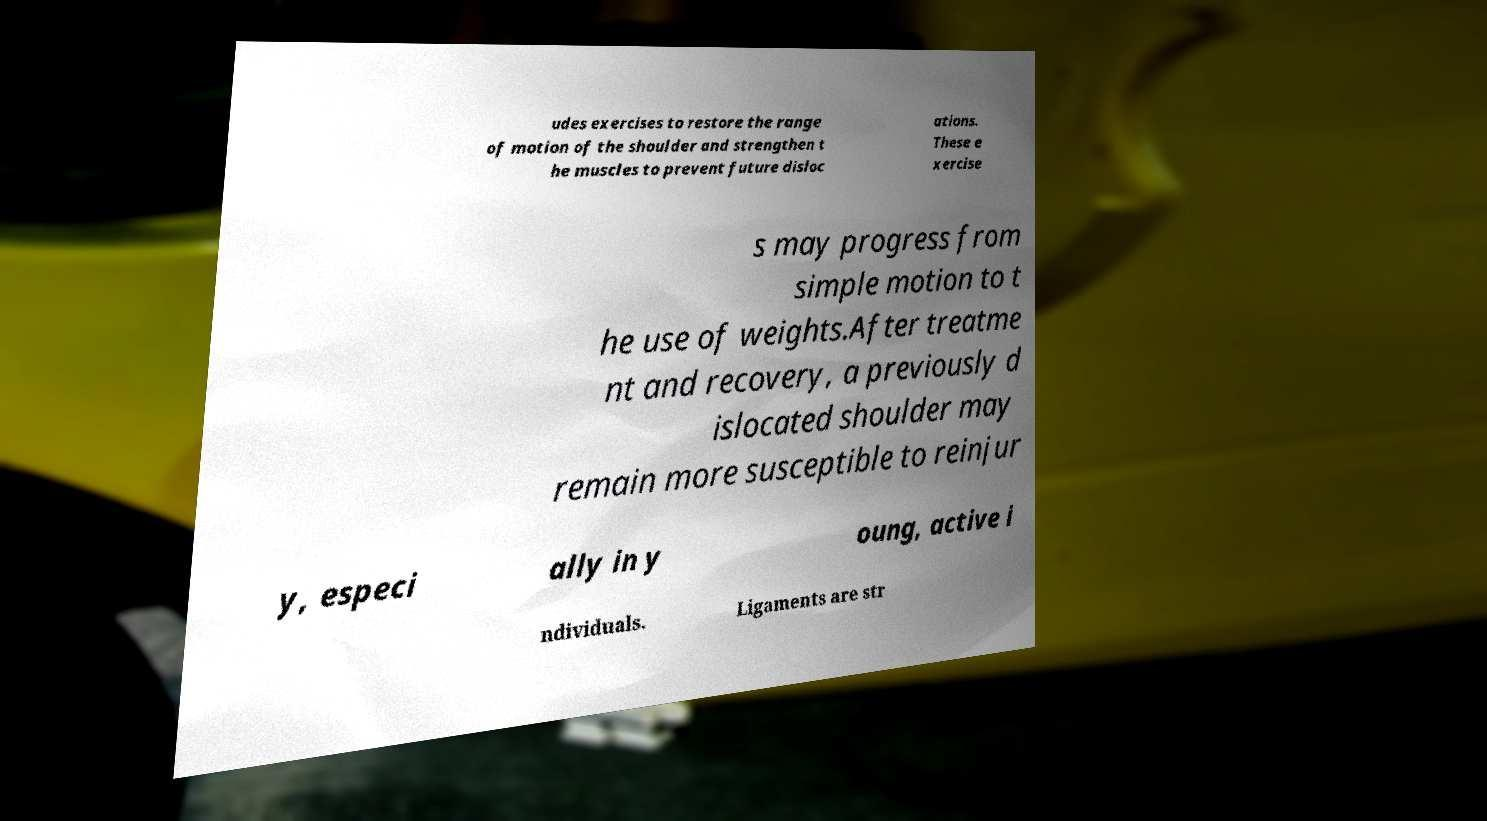Could you extract and type out the text from this image? udes exercises to restore the range of motion of the shoulder and strengthen t he muscles to prevent future disloc ations. These e xercise s may progress from simple motion to t he use of weights.After treatme nt and recovery, a previously d islocated shoulder may remain more susceptible to reinjur y, especi ally in y oung, active i ndividuals. Ligaments are str 